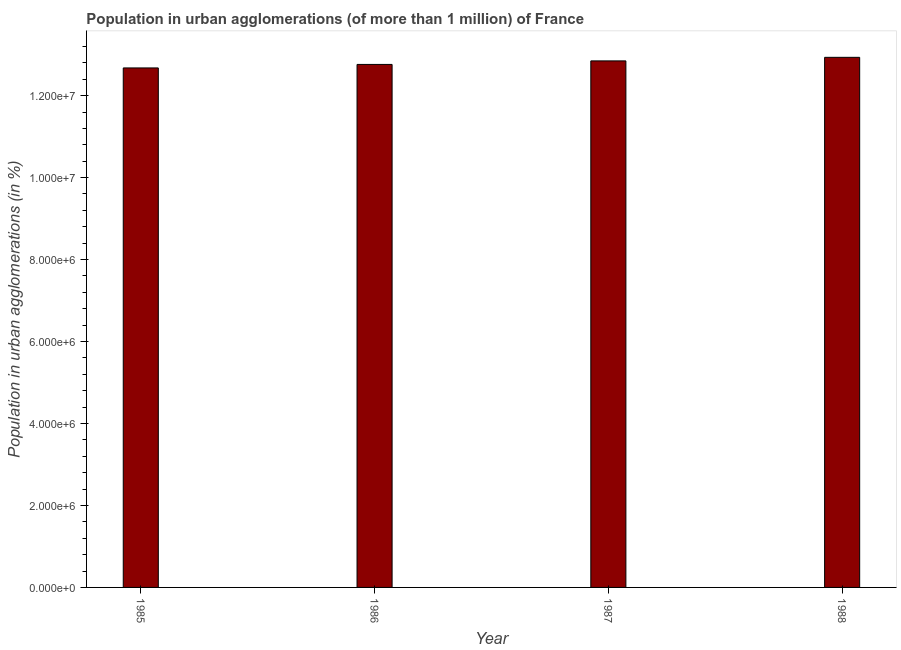Does the graph contain grids?
Provide a succinct answer. No. What is the title of the graph?
Provide a succinct answer. Population in urban agglomerations (of more than 1 million) of France. What is the label or title of the X-axis?
Offer a terse response. Year. What is the label or title of the Y-axis?
Ensure brevity in your answer.  Population in urban agglomerations (in %). What is the population in urban agglomerations in 1985?
Provide a short and direct response. 1.27e+07. Across all years, what is the maximum population in urban agglomerations?
Give a very brief answer. 1.29e+07. Across all years, what is the minimum population in urban agglomerations?
Your answer should be compact. 1.27e+07. In which year was the population in urban agglomerations maximum?
Ensure brevity in your answer.  1988. What is the sum of the population in urban agglomerations?
Keep it short and to the point. 5.12e+07. What is the difference between the population in urban agglomerations in 1985 and 1986?
Ensure brevity in your answer.  -8.55e+04. What is the average population in urban agglomerations per year?
Keep it short and to the point. 1.28e+07. What is the median population in urban agglomerations?
Your answer should be compact. 1.28e+07. In how many years, is the population in urban agglomerations greater than 4400000 %?
Your answer should be compact. 4. Is the population in urban agglomerations in 1986 less than that in 1987?
Your response must be concise. Yes. What is the difference between the highest and the second highest population in urban agglomerations?
Provide a short and direct response. 8.70e+04. Is the sum of the population in urban agglomerations in 1987 and 1988 greater than the maximum population in urban agglomerations across all years?
Make the answer very short. Yes. What is the difference between the highest and the lowest population in urban agglomerations?
Give a very brief answer. 2.59e+05. Are all the bars in the graph horizontal?
Your answer should be very brief. No. What is the difference between two consecutive major ticks on the Y-axis?
Offer a terse response. 2.00e+06. Are the values on the major ticks of Y-axis written in scientific E-notation?
Your answer should be compact. Yes. What is the Population in urban agglomerations (in %) in 1985?
Ensure brevity in your answer.  1.27e+07. What is the Population in urban agglomerations (in %) in 1986?
Give a very brief answer. 1.28e+07. What is the Population in urban agglomerations (in %) of 1987?
Offer a terse response. 1.28e+07. What is the Population in urban agglomerations (in %) in 1988?
Keep it short and to the point. 1.29e+07. What is the difference between the Population in urban agglomerations (in %) in 1985 and 1986?
Make the answer very short. -8.55e+04. What is the difference between the Population in urban agglomerations (in %) in 1985 and 1987?
Make the answer very short. -1.72e+05. What is the difference between the Population in urban agglomerations (in %) in 1985 and 1988?
Make the answer very short. -2.59e+05. What is the difference between the Population in urban agglomerations (in %) in 1986 and 1987?
Give a very brief answer. -8.62e+04. What is the difference between the Population in urban agglomerations (in %) in 1986 and 1988?
Your answer should be compact. -1.73e+05. What is the difference between the Population in urban agglomerations (in %) in 1987 and 1988?
Ensure brevity in your answer.  -8.70e+04. What is the ratio of the Population in urban agglomerations (in %) in 1985 to that in 1986?
Provide a succinct answer. 0.99. What is the ratio of the Population in urban agglomerations (in %) in 1986 to that in 1988?
Provide a succinct answer. 0.99. 